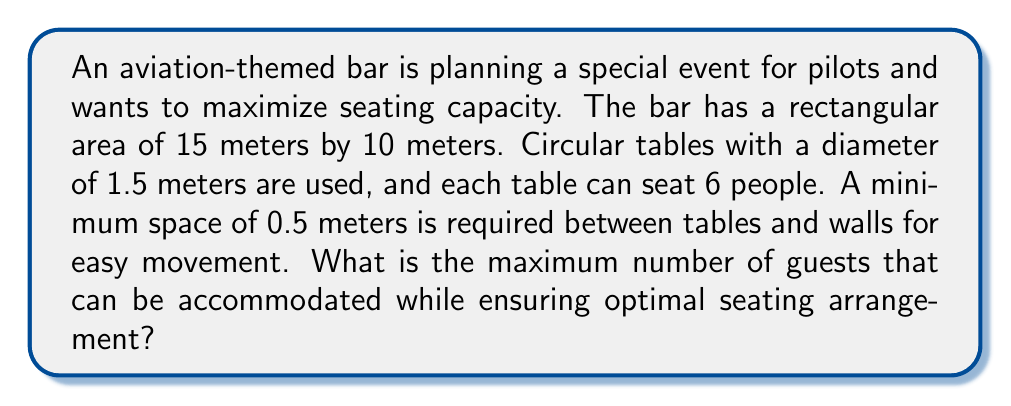Can you answer this question? Let's approach this problem step by step:

1. Calculate the usable area:
   - Total area: $15 \text{ m} \times 10 \text{ m} = 150 \text{ m}^2$
   - Usable area: $(15 - 2 \times 0.5) \text{ m} \times (10 - 2 \times 0.5) \text{ m} = 14 \text{ m} \times 9 \text{ m} = 126 \text{ m}^2$

2. Calculate the area occupied by each table:
   - Table diameter: 1.5 m
   - Table radius: $r = 0.75 \text{ m}$
   - Area of each table: $A = \pi r^2 = \pi \times 0.75^2 \approx 1.77 \text{ m}^2$

3. Calculate the area needed for each table, including the required space:
   - Required space around table: 0.5 m
   - Effective diameter: $1.5 \text{ m} + 2 \times 0.5 \text{ m} = 2.5 \text{ m}$
   - Effective radius: $R = 1.25 \text{ m}$
   - Effective area: $A_{eff} = \pi R^2 = \pi \times 1.25^2 \approx 4.91 \text{ m}^2$

4. Calculate the maximum number of tables that can fit:
   - Number of tables = Usable area / Effective area per table
   - $N_{tables} = 126 \text{ m}^2 / 4.91 \text{ m}^2 \approx 25.66$
   - Rounding down: 25 tables

5. Calculate the maximum number of guests:
   - Each table seats 6 people
   - Maximum guests = Number of tables × Guests per table
   - $N_{guests} = 25 \times 6 = 150$

Therefore, the maximum number of guests that can be accommodated is 150.
Answer: 150 guests 